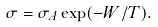Convert formula to latex. <formula><loc_0><loc_0><loc_500><loc_500>\sigma = \sigma _ { A } \exp ( - W / T ) .</formula> 